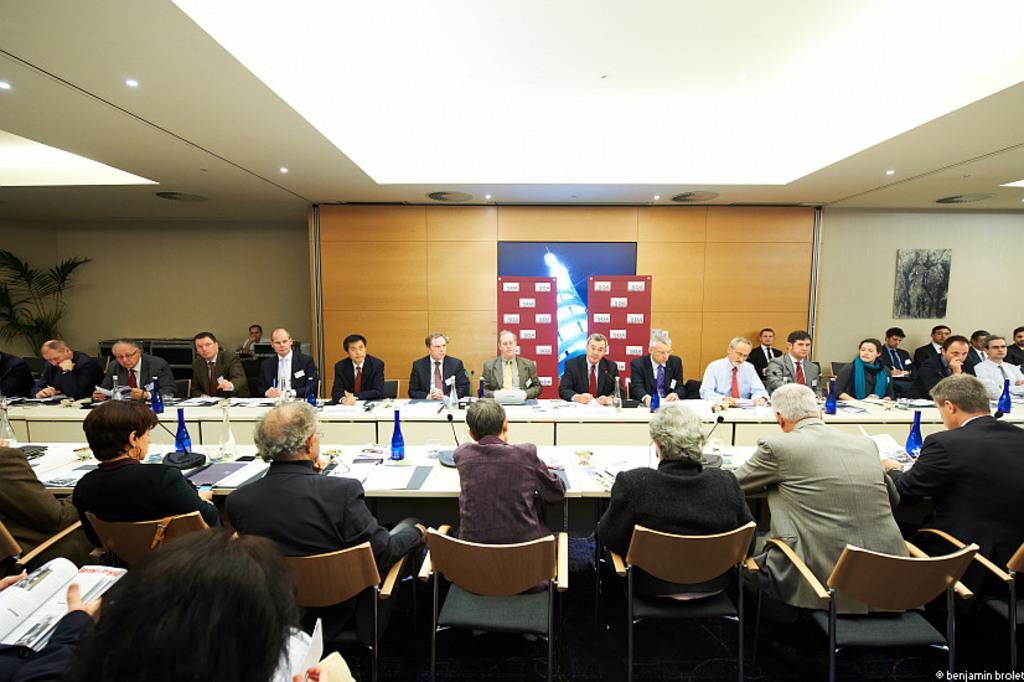Please provide a concise description of this image. In this picture there are group of people who are sitting on the chair. There is a bottle, file, paper, mic and other objects on the table. There is a light, frame on the wall. There is a plant. 